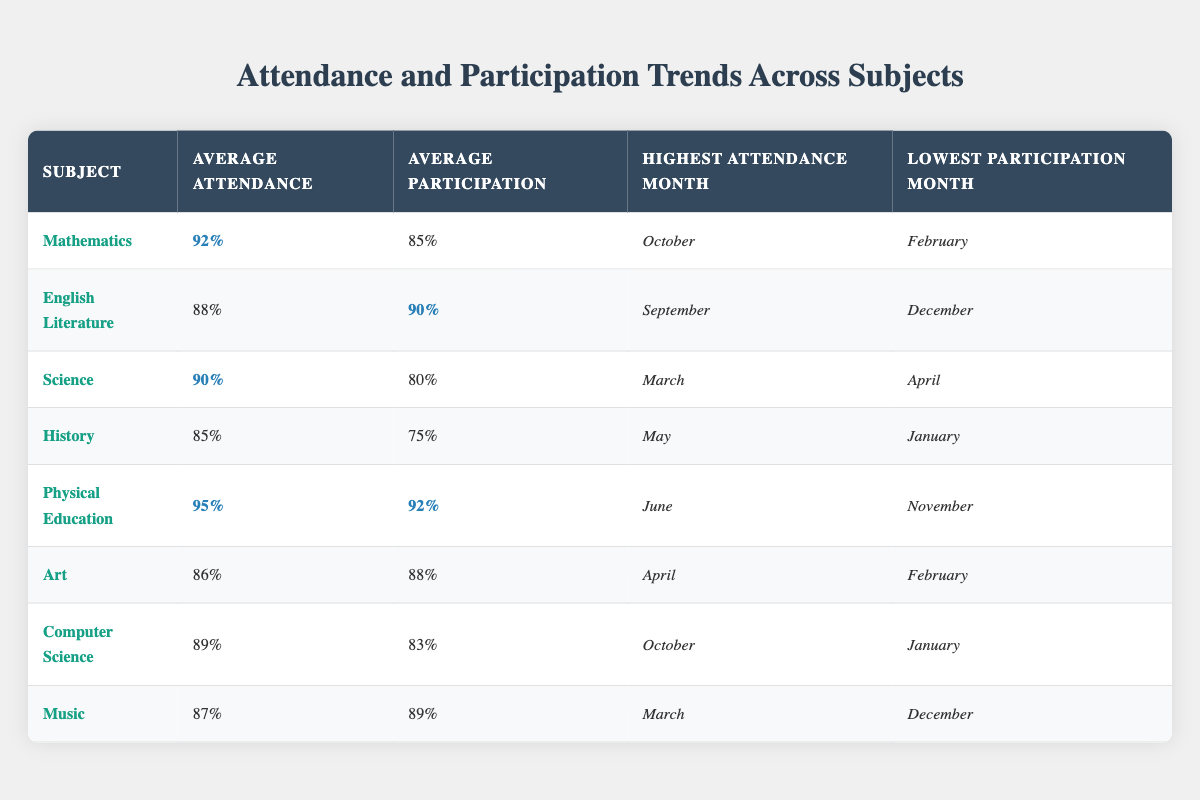What is the average attendance for Physical Education? The table shows that the average attendance for Physical Education is highlighted as **95%**.
Answer: 95% Which subject has the highest average participation? By comparing the average participation values across all subjects, English Literature has the highest average at **90%**.
Answer: 90% What is the lowest participation month for Science? The table indicates that the lowest participation month for Science is **April**.
Answer: April How does the average attendance in History compare to that in Music? The average attendance for History is **85%**, while Music has an average attendance of **87%**. Hence, Music has a higher average attendance by **2%**.
Answer: 2% True or False: The attendance in Art is higher than that in Computer Science. For Art, the average attendance is **86%** and for Computer Science, it is **89%**. Since **86%** is less than **89%**, the statement is False.
Answer: False What are the attendance percentages for the highest attendance months in Mathematics and Physical Education? The highest attendance month for Mathematics is **October** with **92%**, while for Physical Education, it is **June** with **95%**.
Answer: 92% (October), 95% (June) What is the difference between the average participation of English Literature and History? The average participation for English Literature is **90%** and for History, it is **75%**. The difference is calculated as **90% - 75% = 15%**.
Answer: 15% Which subject consistently has the highest participation month? Upon checking each subject's lowest participation month, both Physical Education and English Literature do not have February as their lowest participation month. Therefore, based on this data, Physical Education, with its highest attendance month of **June**, consistently shows better engagement.
Answer: Physical Education What is the average attendance for subjects with participation over 85%? The average attendance for Mathematics (**92%**), English Literature (**88%**), Physical Education (**95%**), Art (**86%**), and Music (**87%**) needs to be calculated. Summing them gives **92 + 88 + 95 + 86 + 87 = 448**, and dividing by **5** gives an average of **89.6%**.
Answer: 89.6% Which subject has the largest gap between average attendance and average participation? The gaps are calculated as follows: Mathematics: (92 - 85 = 7), English Literature: (88 - 90 = -2), Science: (90 - 80 = 10), History: (85 - 75 = 10), Physical Education: (95 - 92 = 3), Art: (86 - 88 = -2), Computer Science: (89 - 83 = 6), Music: (87 - 89 = -2). History and Science both have the largest gap of **10%**.
Answer: 10% 